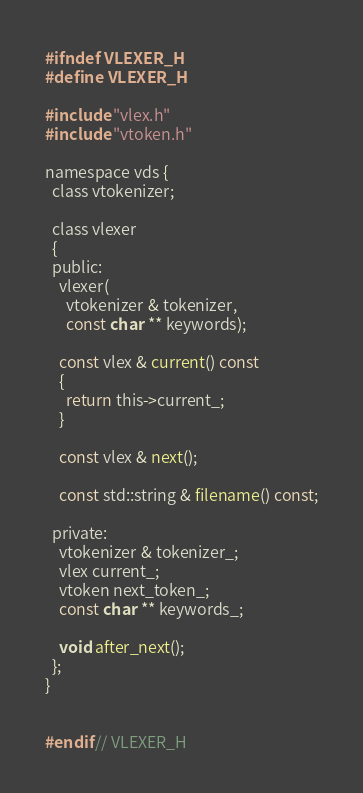Convert code to text. <code><loc_0><loc_0><loc_500><loc_500><_C_>#ifndef VLEXER_H
#define VLEXER_H

#include "vlex.h"
#include "vtoken.h"

namespace vds {
  class vtokenizer;
  
  class vlexer
  {
  public:
    vlexer(
      vtokenizer & tokenizer,
      const char ** keywords);
       
    const vlex & current() const
    {
      return this->current_;
    }
    
    const vlex & next();
    
    const std::string & filename() const;
   
  private:
    vtokenizer & tokenizer_;
    vlex current_;
    vtoken next_token_;
    const char ** keywords_;
    
    void after_next();
  };
}


#endif // VLEXER_H
</code> 